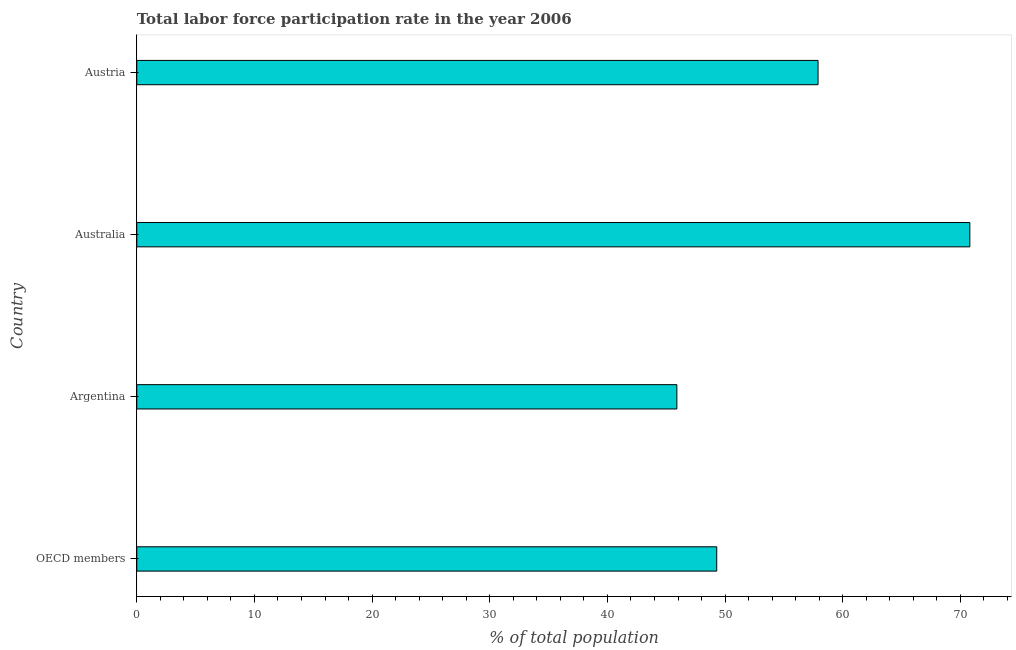Does the graph contain any zero values?
Your answer should be compact. No. Does the graph contain grids?
Ensure brevity in your answer.  No. What is the title of the graph?
Give a very brief answer. Total labor force participation rate in the year 2006. What is the label or title of the X-axis?
Provide a succinct answer. % of total population. What is the label or title of the Y-axis?
Provide a succinct answer. Country. What is the total labor force participation rate in Australia?
Give a very brief answer. 70.8. Across all countries, what is the maximum total labor force participation rate?
Your response must be concise. 70.8. Across all countries, what is the minimum total labor force participation rate?
Ensure brevity in your answer.  45.9. What is the sum of the total labor force participation rate?
Provide a succinct answer. 223.89. What is the average total labor force participation rate per country?
Your response must be concise. 55.97. What is the median total labor force participation rate?
Make the answer very short. 53.59. In how many countries, is the total labor force participation rate greater than 4 %?
Keep it short and to the point. 4. What is the ratio of the total labor force participation rate in Austria to that in OECD members?
Offer a terse response. 1.18. Is the total labor force participation rate in Argentina less than that in Australia?
Your response must be concise. Yes. Is the difference between the total labor force participation rate in Argentina and Austria greater than the difference between any two countries?
Your answer should be compact. No. Is the sum of the total labor force participation rate in Australia and OECD members greater than the maximum total labor force participation rate across all countries?
Keep it short and to the point. Yes. What is the difference between the highest and the lowest total labor force participation rate?
Offer a very short reply. 24.9. Are all the bars in the graph horizontal?
Your answer should be compact. Yes. How many countries are there in the graph?
Offer a terse response. 4. Are the values on the major ticks of X-axis written in scientific E-notation?
Offer a terse response. No. What is the % of total population in OECD members?
Give a very brief answer. 49.29. What is the % of total population in Argentina?
Provide a succinct answer. 45.9. What is the % of total population in Australia?
Keep it short and to the point. 70.8. What is the % of total population of Austria?
Give a very brief answer. 57.9. What is the difference between the % of total population in OECD members and Argentina?
Make the answer very short. 3.39. What is the difference between the % of total population in OECD members and Australia?
Ensure brevity in your answer.  -21.51. What is the difference between the % of total population in OECD members and Austria?
Ensure brevity in your answer.  -8.61. What is the difference between the % of total population in Argentina and Australia?
Give a very brief answer. -24.9. What is the difference between the % of total population in Argentina and Austria?
Provide a succinct answer. -12. What is the difference between the % of total population in Australia and Austria?
Give a very brief answer. 12.9. What is the ratio of the % of total population in OECD members to that in Argentina?
Ensure brevity in your answer.  1.07. What is the ratio of the % of total population in OECD members to that in Australia?
Provide a short and direct response. 0.7. What is the ratio of the % of total population in OECD members to that in Austria?
Make the answer very short. 0.85. What is the ratio of the % of total population in Argentina to that in Australia?
Your answer should be compact. 0.65. What is the ratio of the % of total population in Argentina to that in Austria?
Ensure brevity in your answer.  0.79. What is the ratio of the % of total population in Australia to that in Austria?
Make the answer very short. 1.22. 